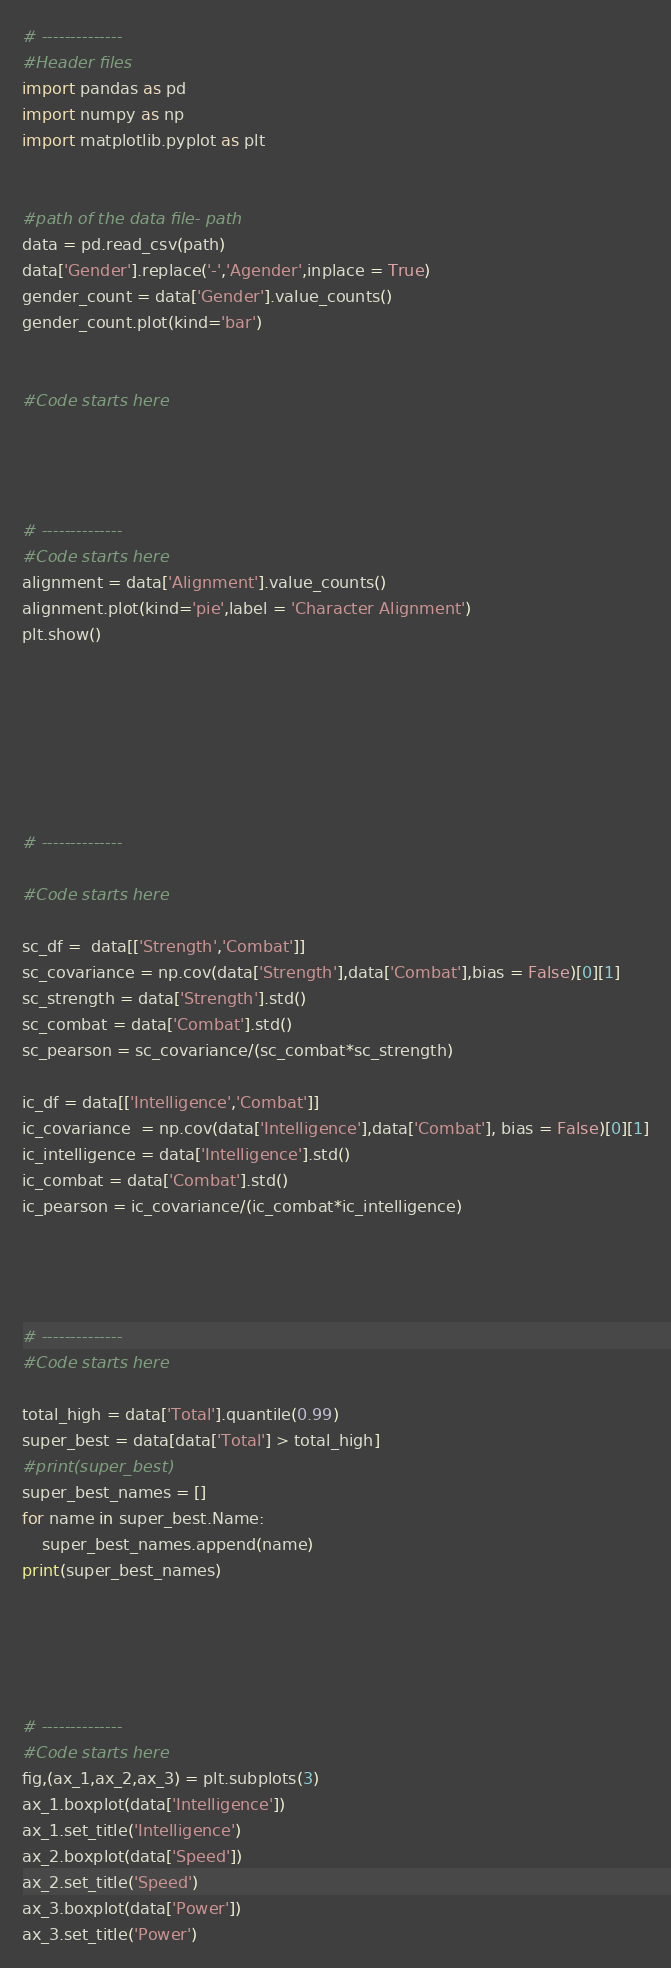Convert code to text. <code><loc_0><loc_0><loc_500><loc_500><_Python_># --------------
#Header files
import pandas as pd
import numpy as np
import matplotlib.pyplot as plt


#path of the data file- path
data = pd.read_csv(path)
data['Gender'].replace('-','Agender',inplace = True)
gender_count = data['Gender'].value_counts()
gender_count.plot(kind='bar')


#Code starts here 




# --------------
#Code starts here
alignment = data['Alignment'].value_counts()
alignment.plot(kind='pie',label = 'Character Alignment')
plt.show()







# --------------

#Code starts here

sc_df =  data[['Strength','Combat']]
sc_covariance = np.cov(data['Strength'],data['Combat'],bias = False)[0][1]
sc_strength = data['Strength'].std()
sc_combat = data['Combat'].std()
sc_pearson = sc_covariance/(sc_combat*sc_strength)

ic_df = data[['Intelligence','Combat']]
ic_covariance  = np.cov(data['Intelligence'],data['Combat'], bias = False)[0][1]
ic_intelligence = data['Intelligence'].std()
ic_combat = data['Combat'].std()
ic_pearson = ic_covariance/(ic_combat*ic_intelligence)




# --------------
#Code starts here

total_high = data['Total'].quantile(0.99)
super_best = data[data['Total'] > total_high]
#print(super_best)
super_best_names = []
for name in super_best.Name:
    super_best_names.append(name)
print(super_best_names)





# --------------
#Code starts here
fig,(ax_1,ax_2,ax_3) = plt.subplots(3)
ax_1.boxplot(data['Intelligence'])
ax_1.set_title('Intelligence')
ax_2.boxplot(data['Speed'])
ax_2.set_title('Speed')
ax_3.boxplot(data['Power'])
ax_3.set_title('Power')









</code> 